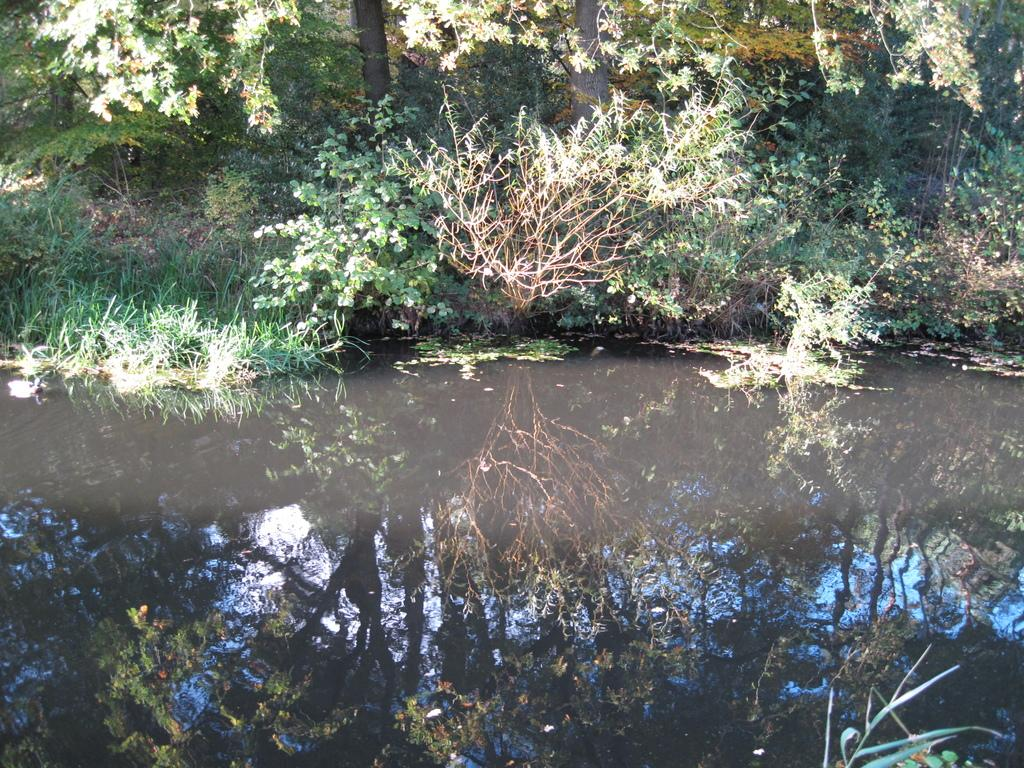What is visible at the bottom of the image? There is water visible at the bottom of the image. What type of vegetation can be seen in the background of the image? There are plants and trees in the background of the image. What type of ground cover is present in the background of the image? There is grass in the background of the image. What type of pipe can be seen in the image? There is no pipe present in the image. Can you describe the scene in the image? The image features water at the bottom and vegetation, including plants, trees, and grass, in the background. 